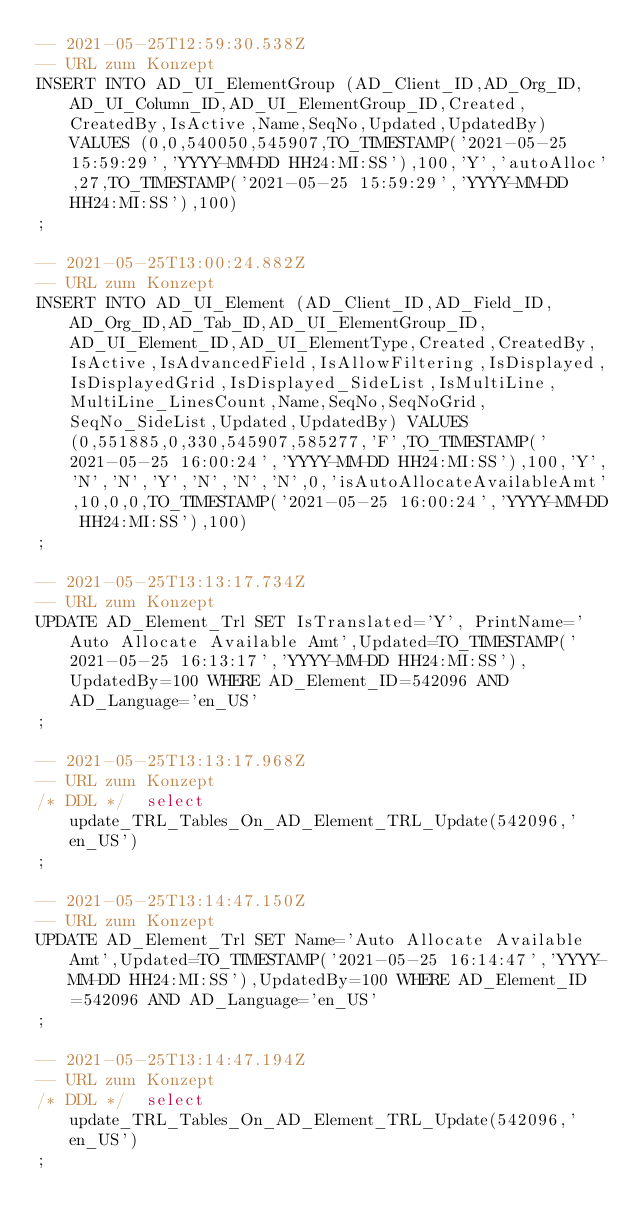<code> <loc_0><loc_0><loc_500><loc_500><_SQL_>-- 2021-05-25T12:59:30.538Z
-- URL zum Konzept
INSERT INTO AD_UI_ElementGroup (AD_Client_ID,AD_Org_ID,AD_UI_Column_ID,AD_UI_ElementGroup_ID,Created,CreatedBy,IsActive,Name,SeqNo,Updated,UpdatedBy) VALUES (0,0,540050,545907,TO_TIMESTAMP('2021-05-25 15:59:29','YYYY-MM-DD HH24:MI:SS'),100,'Y','autoAlloc',27,TO_TIMESTAMP('2021-05-25 15:59:29','YYYY-MM-DD HH24:MI:SS'),100)
;

-- 2021-05-25T13:00:24.882Z
-- URL zum Konzept
INSERT INTO AD_UI_Element (AD_Client_ID,AD_Field_ID,AD_Org_ID,AD_Tab_ID,AD_UI_ElementGroup_ID,AD_UI_Element_ID,AD_UI_ElementType,Created,CreatedBy,IsActive,IsAdvancedField,IsAllowFiltering,IsDisplayed,IsDisplayedGrid,IsDisplayed_SideList,IsMultiLine,MultiLine_LinesCount,Name,SeqNo,SeqNoGrid,SeqNo_SideList,Updated,UpdatedBy) VALUES (0,551885,0,330,545907,585277,'F',TO_TIMESTAMP('2021-05-25 16:00:24','YYYY-MM-DD HH24:MI:SS'),100,'Y','N','N','Y','N','N','N',0,'isAutoAllocateAvailableAmt',10,0,0,TO_TIMESTAMP('2021-05-25 16:00:24','YYYY-MM-DD HH24:MI:SS'),100)
;

-- 2021-05-25T13:13:17.734Z
-- URL zum Konzept
UPDATE AD_Element_Trl SET IsTranslated='Y', PrintName='Auto Allocate Available Amt',Updated=TO_TIMESTAMP('2021-05-25 16:13:17','YYYY-MM-DD HH24:MI:SS'),UpdatedBy=100 WHERE AD_Element_ID=542096 AND AD_Language='en_US'
;

-- 2021-05-25T13:13:17.968Z
-- URL zum Konzept
/* DDL */  select update_TRL_Tables_On_AD_Element_TRL_Update(542096,'en_US') 
;

-- 2021-05-25T13:14:47.150Z
-- URL zum Konzept
UPDATE AD_Element_Trl SET Name='Auto Allocate Available Amt',Updated=TO_TIMESTAMP('2021-05-25 16:14:47','YYYY-MM-DD HH24:MI:SS'),UpdatedBy=100 WHERE AD_Element_ID=542096 AND AD_Language='en_US'
;

-- 2021-05-25T13:14:47.194Z
-- URL zum Konzept
/* DDL */  select update_TRL_Tables_On_AD_Element_TRL_Update(542096,'en_US') 
;
</code> 